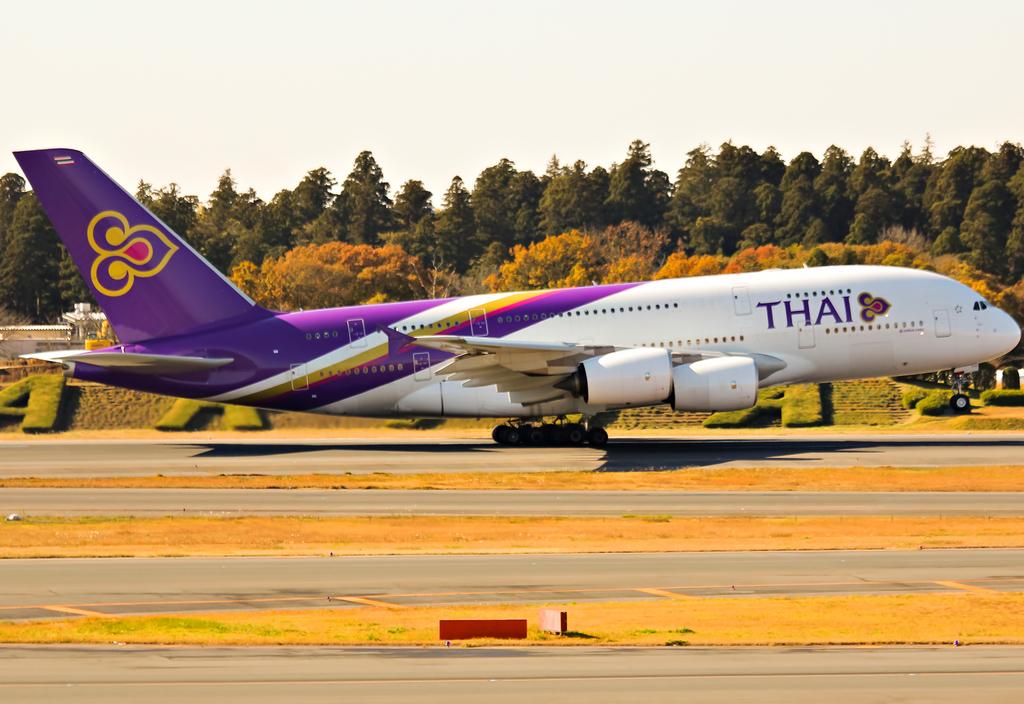What is the airline of the jet?
Ensure brevity in your answer.  Thai. What letter is shaped in the grass?
Make the answer very short. A. 